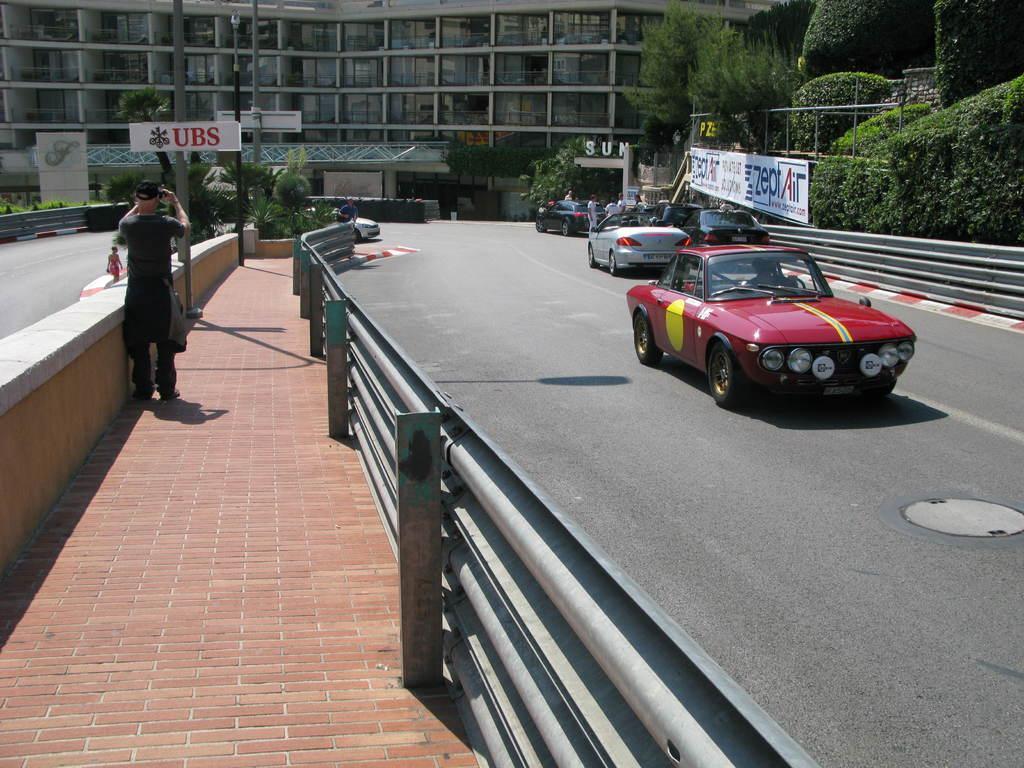Describe this image in one or two sentences. On the right side there is a road. On that there are many vehicles. On the sides of the road there are railings. On the left side there is a sidewalk. On that there is a person standing. In the back there is a building. On the sides there are poles. On the pole there is a board. Also there is a banner. On the right side there are trees. 